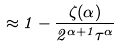<formula> <loc_0><loc_0><loc_500><loc_500>\approx 1 - \frac { \zeta ( \alpha ) } { 2 ^ { \alpha + 1 } \tau ^ { \alpha } }</formula> 